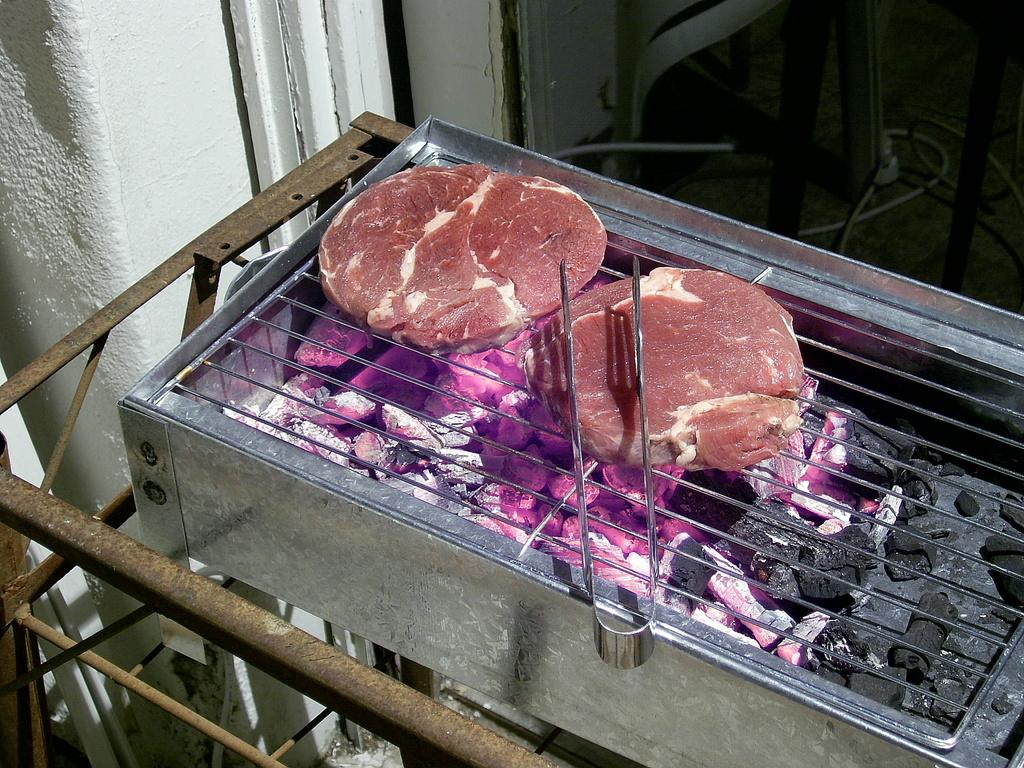What is the main object in the image? There is a grill in the image. What is used to heat the grill? The grill has coal. What is being cooked on the grill? There are items on the grill. What is the color of the items on the grill? The items on the grill are silver in color. Where is the ring located in the image? There is no ring present in the image. Can you describe the seat on the grill? There is no seat present on the grill; it is a cooking surface for items. 